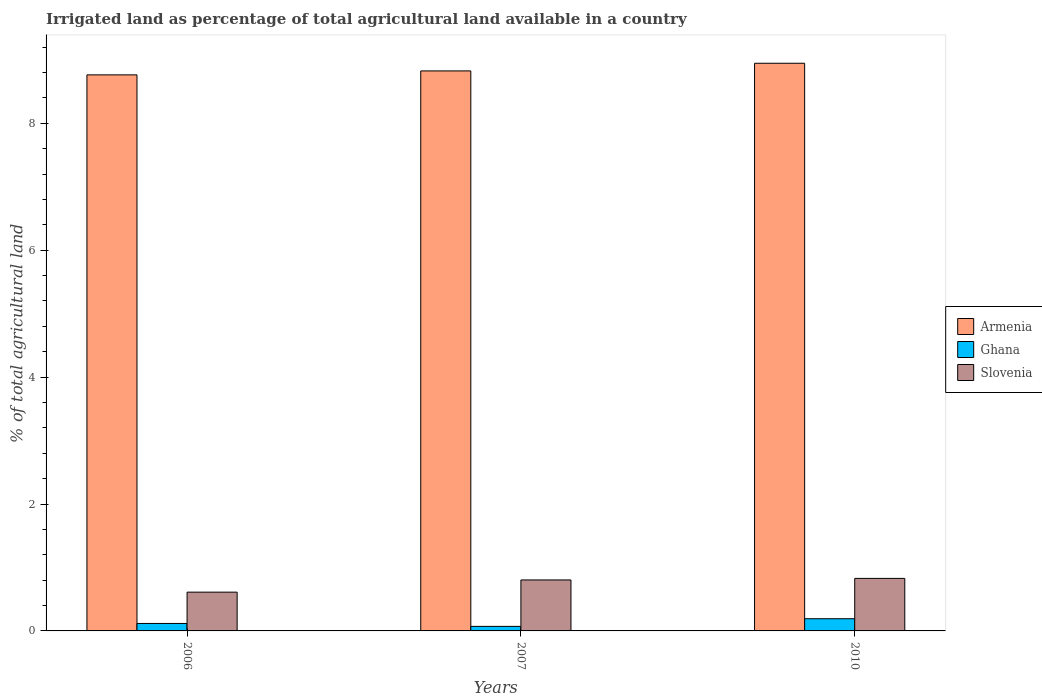How many different coloured bars are there?
Your response must be concise. 3. How many groups of bars are there?
Offer a terse response. 3. Are the number of bars per tick equal to the number of legend labels?
Provide a short and direct response. Yes. Are the number of bars on each tick of the X-axis equal?
Your answer should be very brief. Yes. How many bars are there on the 1st tick from the right?
Offer a very short reply. 3. What is the label of the 1st group of bars from the left?
Your answer should be compact. 2006. What is the percentage of irrigated land in Ghana in 2010?
Your response must be concise. 0.19. Across all years, what is the maximum percentage of irrigated land in Slovenia?
Offer a terse response. 0.83. Across all years, what is the minimum percentage of irrigated land in Ghana?
Give a very brief answer. 0.07. In which year was the percentage of irrigated land in Slovenia minimum?
Provide a succinct answer. 2006. What is the total percentage of irrigated land in Armenia in the graph?
Ensure brevity in your answer.  26.53. What is the difference between the percentage of irrigated land in Ghana in 2006 and that in 2007?
Your answer should be compact. 0.05. What is the difference between the percentage of irrigated land in Ghana in 2010 and the percentage of irrigated land in Armenia in 2006?
Provide a succinct answer. -8.57. What is the average percentage of irrigated land in Slovenia per year?
Ensure brevity in your answer.  0.75. In the year 2007, what is the difference between the percentage of irrigated land in Slovenia and percentage of irrigated land in Ghana?
Offer a very short reply. 0.73. What is the ratio of the percentage of irrigated land in Slovenia in 2006 to that in 2010?
Make the answer very short. 0.74. Is the percentage of irrigated land in Slovenia in 2007 less than that in 2010?
Provide a short and direct response. Yes. Is the difference between the percentage of irrigated land in Slovenia in 2007 and 2010 greater than the difference between the percentage of irrigated land in Ghana in 2007 and 2010?
Offer a very short reply. Yes. What is the difference between the highest and the second highest percentage of irrigated land in Ghana?
Your response must be concise. 0.07. What is the difference between the highest and the lowest percentage of irrigated land in Ghana?
Provide a succinct answer. 0.12. Is the sum of the percentage of irrigated land in Armenia in 2006 and 2010 greater than the maximum percentage of irrigated land in Ghana across all years?
Make the answer very short. Yes. What does the 2nd bar from the left in 2010 represents?
Keep it short and to the point. Ghana. How many bars are there?
Provide a succinct answer. 9. Are all the bars in the graph horizontal?
Provide a succinct answer. No. Does the graph contain any zero values?
Your response must be concise. No. What is the title of the graph?
Give a very brief answer. Irrigated land as percentage of total agricultural land available in a country. What is the label or title of the Y-axis?
Make the answer very short. % of total agricultural land. What is the % of total agricultural land of Armenia in 2006?
Give a very brief answer. 8.76. What is the % of total agricultural land of Ghana in 2006?
Your response must be concise. 0.12. What is the % of total agricultural land of Slovenia in 2006?
Keep it short and to the point. 0.61. What is the % of total agricultural land in Armenia in 2007?
Your answer should be very brief. 8.82. What is the % of total agricultural land of Ghana in 2007?
Your answer should be very brief. 0.07. What is the % of total agricultural land of Slovenia in 2007?
Offer a very short reply. 0.8. What is the % of total agricultural land of Armenia in 2010?
Keep it short and to the point. 8.95. What is the % of total agricultural land in Ghana in 2010?
Offer a very short reply. 0.19. What is the % of total agricultural land in Slovenia in 2010?
Offer a very short reply. 0.83. Across all years, what is the maximum % of total agricultural land in Armenia?
Make the answer very short. 8.95. Across all years, what is the maximum % of total agricultural land in Ghana?
Provide a short and direct response. 0.19. Across all years, what is the maximum % of total agricultural land of Slovenia?
Offer a terse response. 0.83. Across all years, what is the minimum % of total agricultural land of Armenia?
Your answer should be compact. 8.76. Across all years, what is the minimum % of total agricultural land in Ghana?
Provide a short and direct response. 0.07. Across all years, what is the minimum % of total agricultural land of Slovenia?
Offer a terse response. 0.61. What is the total % of total agricultural land in Armenia in the graph?
Your response must be concise. 26.53. What is the total % of total agricultural land of Ghana in the graph?
Offer a terse response. 0.38. What is the total % of total agricultural land in Slovenia in the graph?
Make the answer very short. 2.24. What is the difference between the % of total agricultural land in Armenia in 2006 and that in 2007?
Offer a very short reply. -0.06. What is the difference between the % of total agricultural land in Ghana in 2006 and that in 2007?
Offer a very short reply. 0.05. What is the difference between the % of total agricultural land of Slovenia in 2006 and that in 2007?
Provide a succinct answer. -0.19. What is the difference between the % of total agricultural land in Armenia in 2006 and that in 2010?
Your response must be concise. -0.18. What is the difference between the % of total agricultural land of Ghana in 2006 and that in 2010?
Your answer should be compact. -0.07. What is the difference between the % of total agricultural land of Slovenia in 2006 and that in 2010?
Your answer should be compact. -0.22. What is the difference between the % of total agricultural land in Armenia in 2007 and that in 2010?
Your response must be concise. -0.12. What is the difference between the % of total agricultural land in Ghana in 2007 and that in 2010?
Your response must be concise. -0.12. What is the difference between the % of total agricultural land in Slovenia in 2007 and that in 2010?
Your answer should be compact. -0.02. What is the difference between the % of total agricultural land in Armenia in 2006 and the % of total agricultural land in Ghana in 2007?
Your answer should be compact. 8.69. What is the difference between the % of total agricultural land in Armenia in 2006 and the % of total agricultural land in Slovenia in 2007?
Ensure brevity in your answer.  7.96. What is the difference between the % of total agricultural land of Ghana in 2006 and the % of total agricultural land of Slovenia in 2007?
Your answer should be very brief. -0.69. What is the difference between the % of total agricultural land of Armenia in 2006 and the % of total agricultural land of Ghana in 2010?
Your response must be concise. 8.57. What is the difference between the % of total agricultural land of Armenia in 2006 and the % of total agricultural land of Slovenia in 2010?
Offer a very short reply. 7.93. What is the difference between the % of total agricultural land of Ghana in 2006 and the % of total agricultural land of Slovenia in 2010?
Provide a short and direct response. -0.71. What is the difference between the % of total agricultural land of Armenia in 2007 and the % of total agricultural land of Ghana in 2010?
Provide a short and direct response. 8.63. What is the difference between the % of total agricultural land of Armenia in 2007 and the % of total agricultural land of Slovenia in 2010?
Provide a succinct answer. 8. What is the difference between the % of total agricultural land of Ghana in 2007 and the % of total agricultural land of Slovenia in 2010?
Make the answer very short. -0.76. What is the average % of total agricultural land of Armenia per year?
Provide a short and direct response. 8.84. What is the average % of total agricultural land in Ghana per year?
Offer a very short reply. 0.13. What is the average % of total agricultural land of Slovenia per year?
Provide a succinct answer. 0.75. In the year 2006, what is the difference between the % of total agricultural land of Armenia and % of total agricultural land of Ghana?
Your response must be concise. 8.64. In the year 2006, what is the difference between the % of total agricultural land in Armenia and % of total agricultural land in Slovenia?
Provide a succinct answer. 8.15. In the year 2006, what is the difference between the % of total agricultural land of Ghana and % of total agricultural land of Slovenia?
Offer a very short reply. -0.49. In the year 2007, what is the difference between the % of total agricultural land in Armenia and % of total agricultural land in Ghana?
Ensure brevity in your answer.  8.75. In the year 2007, what is the difference between the % of total agricultural land of Armenia and % of total agricultural land of Slovenia?
Make the answer very short. 8.02. In the year 2007, what is the difference between the % of total agricultural land in Ghana and % of total agricultural land in Slovenia?
Your answer should be compact. -0.73. In the year 2010, what is the difference between the % of total agricultural land in Armenia and % of total agricultural land in Ghana?
Offer a very short reply. 8.75. In the year 2010, what is the difference between the % of total agricultural land of Armenia and % of total agricultural land of Slovenia?
Your answer should be very brief. 8.12. In the year 2010, what is the difference between the % of total agricultural land in Ghana and % of total agricultural land in Slovenia?
Provide a succinct answer. -0.64. What is the ratio of the % of total agricultural land in Ghana in 2006 to that in 2007?
Offer a very short reply. 1.65. What is the ratio of the % of total agricultural land of Slovenia in 2006 to that in 2007?
Provide a short and direct response. 0.76. What is the ratio of the % of total agricultural land of Armenia in 2006 to that in 2010?
Give a very brief answer. 0.98. What is the ratio of the % of total agricultural land in Ghana in 2006 to that in 2010?
Your answer should be compact. 0.61. What is the ratio of the % of total agricultural land of Slovenia in 2006 to that in 2010?
Provide a succinct answer. 0.74. What is the ratio of the % of total agricultural land in Armenia in 2007 to that in 2010?
Make the answer very short. 0.99. What is the ratio of the % of total agricultural land in Ghana in 2007 to that in 2010?
Your answer should be very brief. 0.37. What is the ratio of the % of total agricultural land of Slovenia in 2007 to that in 2010?
Provide a succinct answer. 0.97. What is the difference between the highest and the second highest % of total agricultural land of Armenia?
Provide a short and direct response. 0.12. What is the difference between the highest and the second highest % of total agricultural land in Ghana?
Provide a short and direct response. 0.07. What is the difference between the highest and the second highest % of total agricultural land of Slovenia?
Your answer should be compact. 0.02. What is the difference between the highest and the lowest % of total agricultural land of Armenia?
Your response must be concise. 0.18. What is the difference between the highest and the lowest % of total agricultural land of Ghana?
Your response must be concise. 0.12. What is the difference between the highest and the lowest % of total agricultural land of Slovenia?
Offer a very short reply. 0.22. 